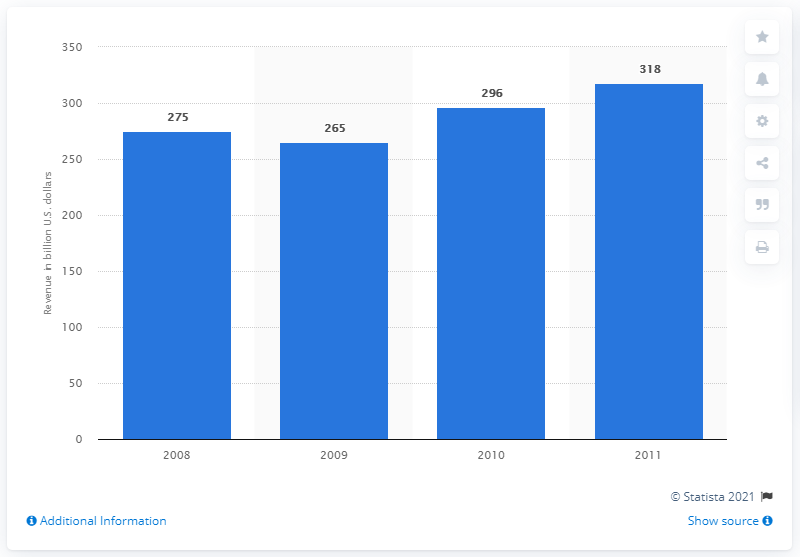Mention a couple of crucial points in this snapshot. In 2011, German companies generated approximately 318 million USD in revenue in the United States. 